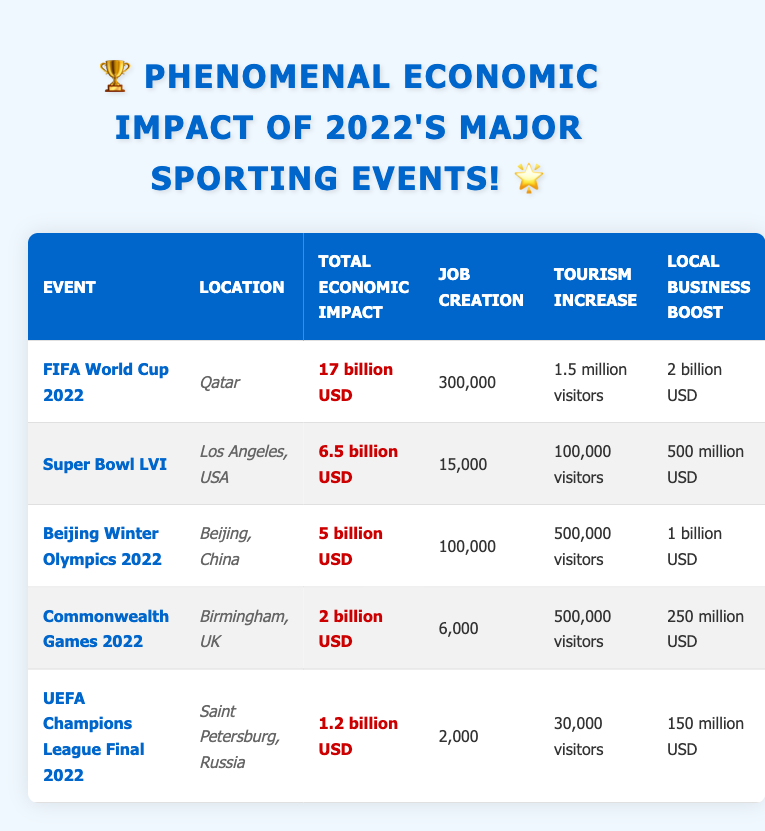What is the total economic impact of the FIFA World Cup 2022? The table shows that the FIFA World Cup 2022 had a total economic impact of 17 billion USD, which is directly stated in the corresponding row.
Answer: 17 billion USD How many jobs were created by the Super Bowl LVI? According to the table, the Super Bowl LVI resulted in the creation of 15,000 jobs, as noted in its specific row.
Answer: 15,000 Which event attracted the most visitors? The FIFA World Cup 2022 had a tourism increase of 1.5 million visitors, which is higher than all other events in the table. All other events have fewer visitors, confirming that FIFA World Cup 2022 had the highest increase.
Answer: FIFA World Cup 2022 What is the combined total economic impact of the Beijing Winter Olympics 2022 and the Commonwealth Games 2022? The total economic impact of the Beijing Winter Olympics is 5 billion USD and for the Commonwealth Games, it is 2 billion USD. Adding these amounts together: 5 billion + 2 billion equals 7 billion USD.
Answer: 7 billion USD Is the local business boost from the UEFA Champions League Final higher than that of the Commonwealth Games? The local business boost for the UEFA Champions League Final is 150 million USD and for the Commonwealth Games, it is 250 million USD. Since 150 million is less than 250 million, the statement is false.
Answer: No Which event had a greater economic impact, the Super Bowl LVI or the Beijing Winter Olympics? The total economic impact for Super Bowl LVI is 6.5 billion USD while for the Beijing Winter Olympics it's 5 billion USD. Comparing these amounts, 6.5 billion is greater, so the Super Bowl LVI had a greater impact.
Answer: Super Bowl LVI What is the average local business boost across all the events listed? To find the average local business boost, we first list the amounts: 2 billion, 500 million, 1 billion, 250 million, and 150 million. Converting these to the same unit, we have 2000 million, 500 million, 1000 million, 250 million, and 150 million. Summing them results in 3900 million, and dividing by 5 (number of events) gives an average of 780 million USD.
Answer: 780 million USD Was there a higher job creation from the FIFA World Cup 2022 compared to the Beijing Winter Olympics 2022? The FIFA World Cup 2022 created 300,000 jobs while the Beijing Winter Olympics 2022 created 100,000 jobs. Since 300,000 is greater than 100,000, the statement is true.
Answer: Yes How many more visitors did the FIFA World Cup 2022 attract compared to the UEFA Champions League Final? The FIFA World Cup attracted 1.5 million visitors while the UEFA Champions League Final attracted 30,000 visitors. Subtracting these values gives 1.5 million minus 30,000, which equals 1.47 million. Thus, FIFA World Cup 2022 attracted 1.47 million more visitors.
Answer: 1.47 million 